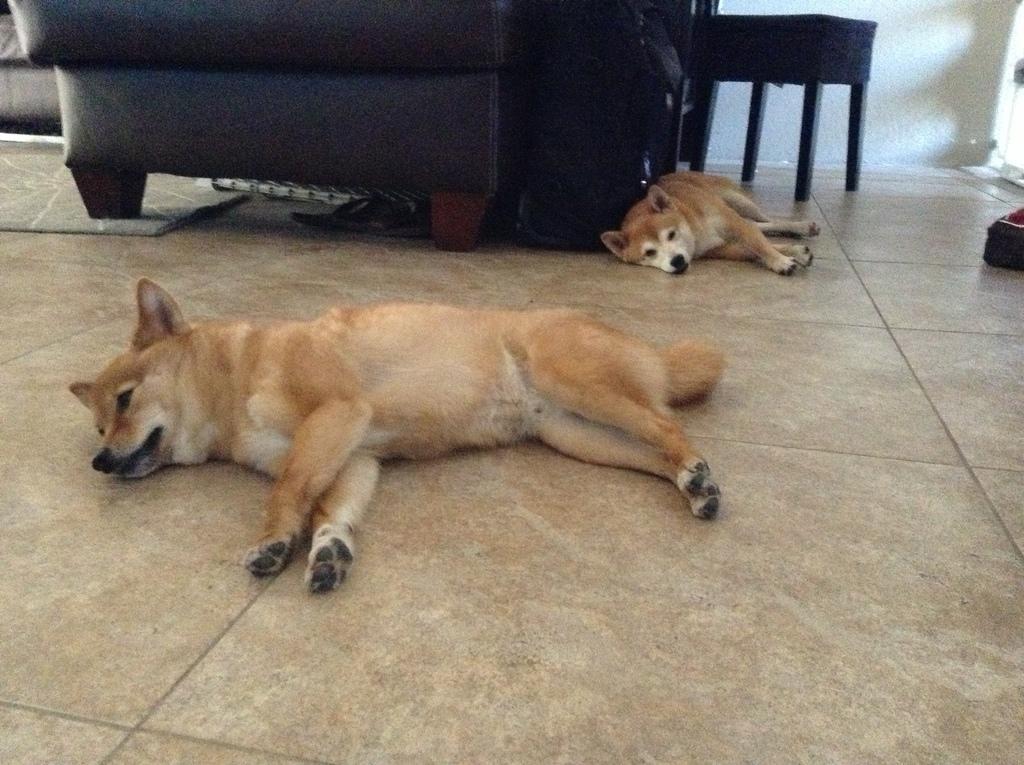In one or two sentences, can you explain what this image depicts? This is the picture there are 2 dogs lying on the floor and at the back ground there is a couch , chair. 